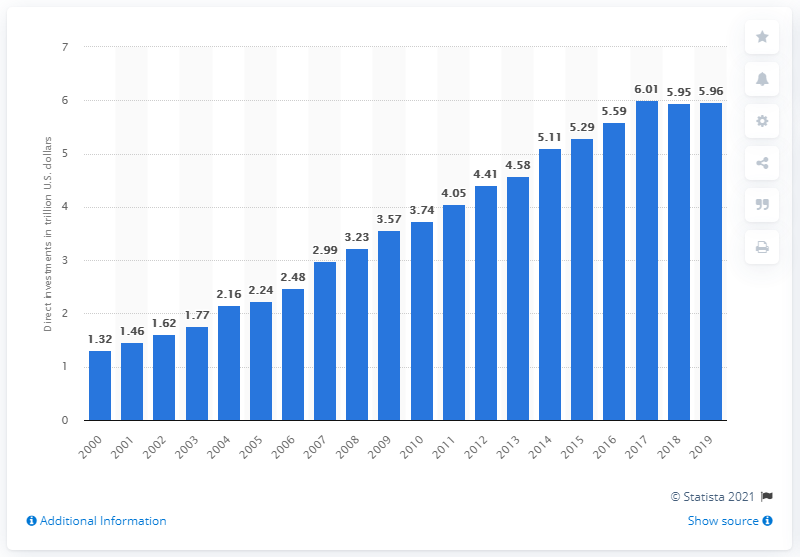Outline some significant characteristics in this image. In 2019, the amount of foreign direct investment from the United States to other countries was 5.96 trillion dollars. 